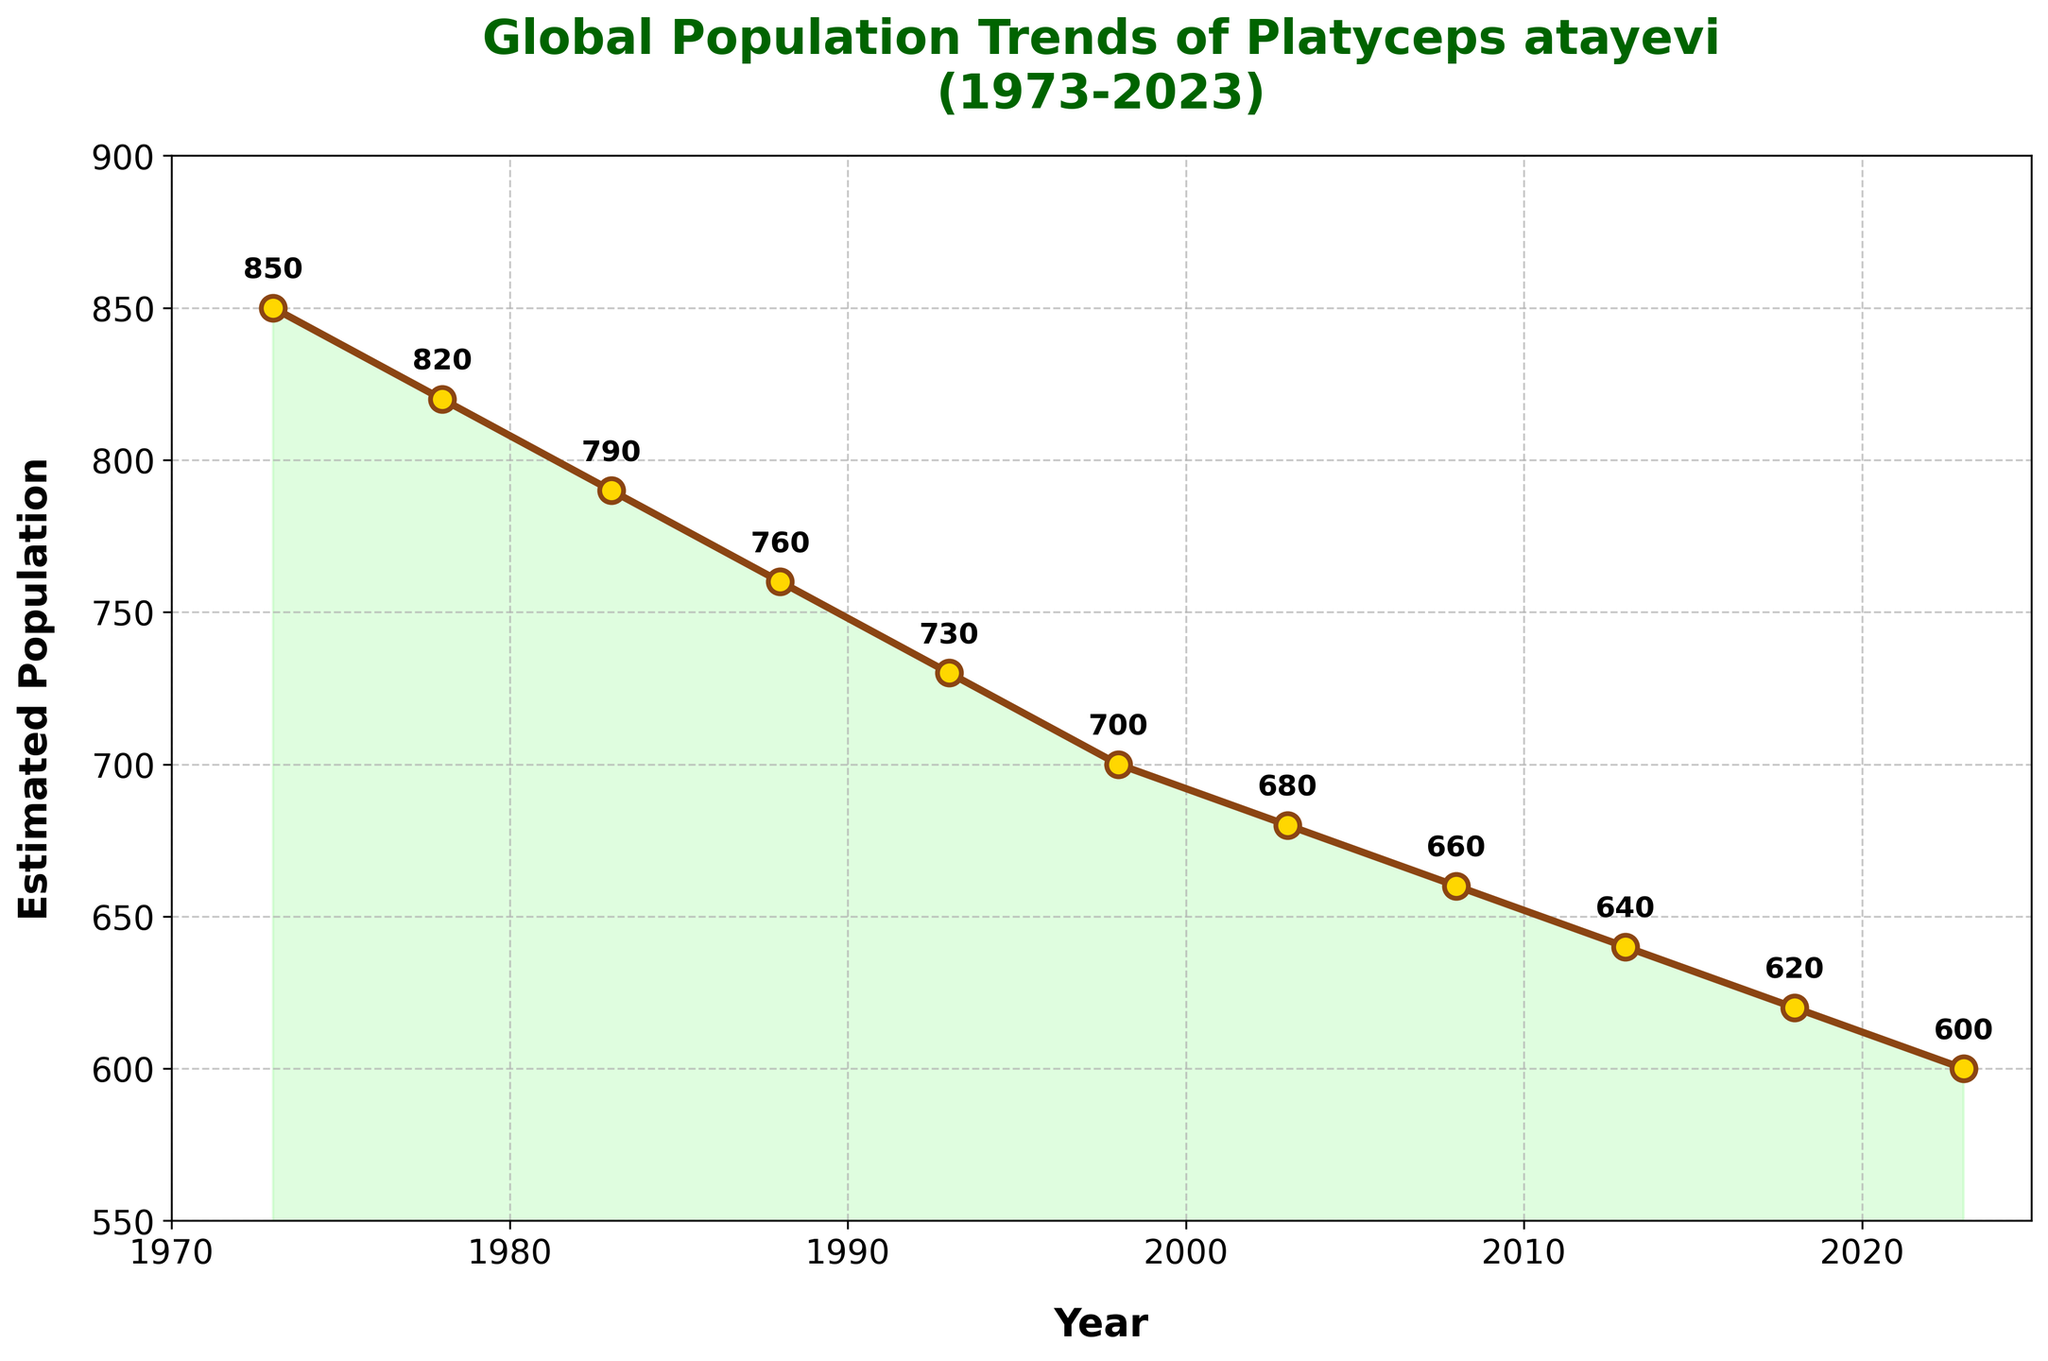What year had the highest estimated population of Platyceps atayevi? The highest data point is at the beginning of the line chart, corresponding to the year 1973 with an estimated population of 850.
Answer: 1973 How has the population of Platyceps atayevi changed from 1973 to 2023? The population has decreased over the years, from 850 in 1973 to 600 in 2023, indicating a downward trend.
Answer: Decreased What is the average estimated population of Platyceps atayevi between 1983 and 2003? Adding the populations for 1983, 1988, 1993, 1998, and 2003 (790 + 760 + 730 + 700 + 680) gives 3660. Dividing by 5 (number of years) gives 732.
Answer: 732 By how much did the population decrease from 1988 to 2018? Subtract the population in 2018 (620) from the population in 1988 (760). The decrease = 760 - 620 = 140.
Answer: 140 Compare the rate of change in population between 1973-1983 and 2013-2023. Which period saw a more significant decline? For 1973-1983, the change is 850 - 790 = 60 (over 10 years); for 2013-2023, the change is 640 - 600 = 40 (over 10 years). The decline was more significant in 1973-1983.
Answer: 1973-1983 At what period did the population cross below 700 for the first time? The population first dropped below 700 between 1993 (730) and 1998 (700) by reaching 700 in 1998.
Answer: 1998 What is the median population value from 1973 to 2023? Arranging the populations in order: 600, 620, 640, 660, 680, 700, 730, 760, 790, 820, 850. The middle value in this series is 700.
Answer: 700 What visual effect is used to emphasize the overall trend? The trend is emphasized by the filled area under the line, which is shaded green.
Answer: Filled area How much did the population change from 1978 to 1983? Subtract the population in 1983 (790) from the population in 1978 (820). The change = 820 - 790 = 30.
Answer: 30 